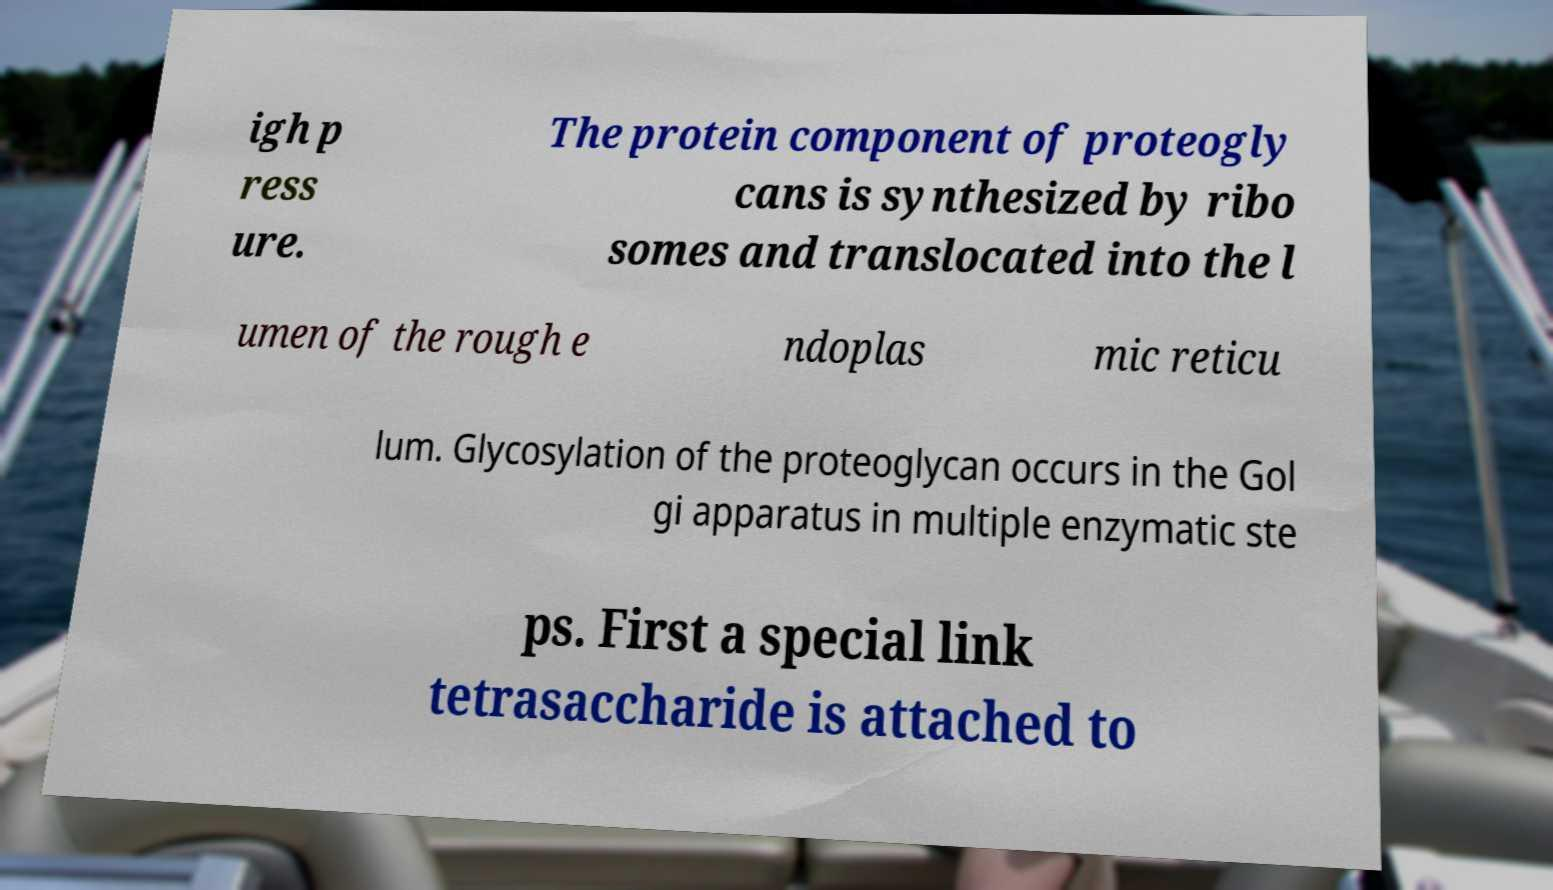For documentation purposes, I need the text within this image transcribed. Could you provide that? igh p ress ure. The protein component of proteogly cans is synthesized by ribo somes and translocated into the l umen of the rough e ndoplas mic reticu lum. Glycosylation of the proteoglycan occurs in the Gol gi apparatus in multiple enzymatic ste ps. First a special link tetrasaccharide is attached to 